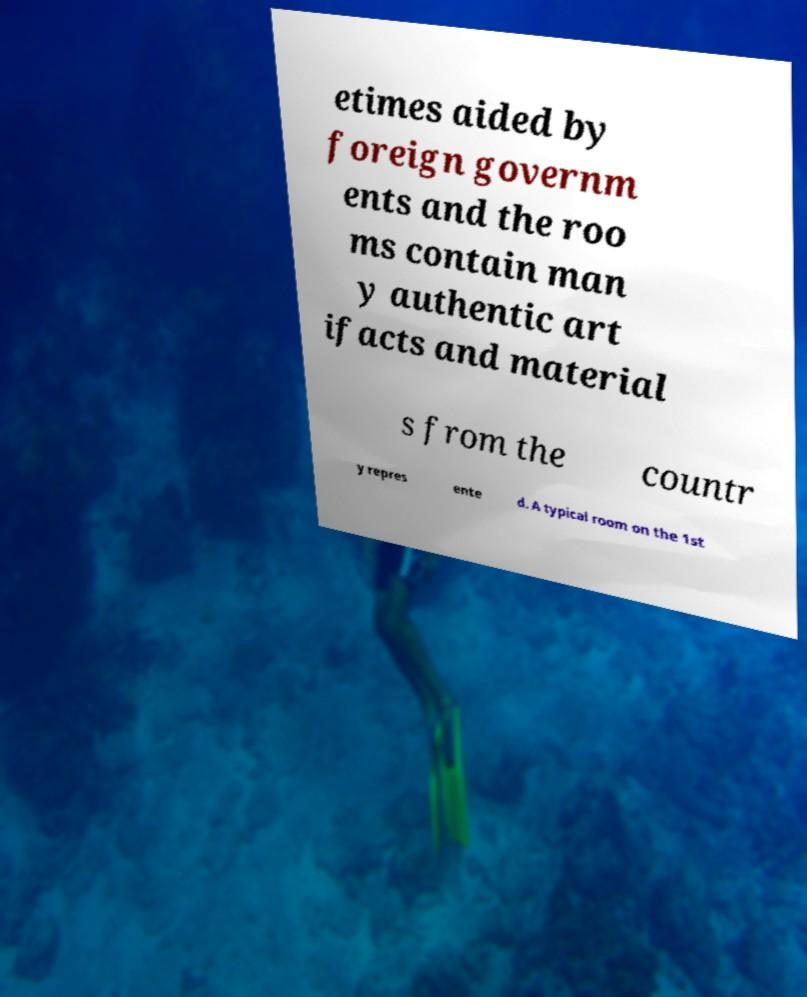Can you read and provide the text displayed in the image?This photo seems to have some interesting text. Can you extract and type it out for me? etimes aided by foreign governm ents and the roo ms contain man y authentic art ifacts and material s from the countr y repres ente d. A typical room on the 1st 